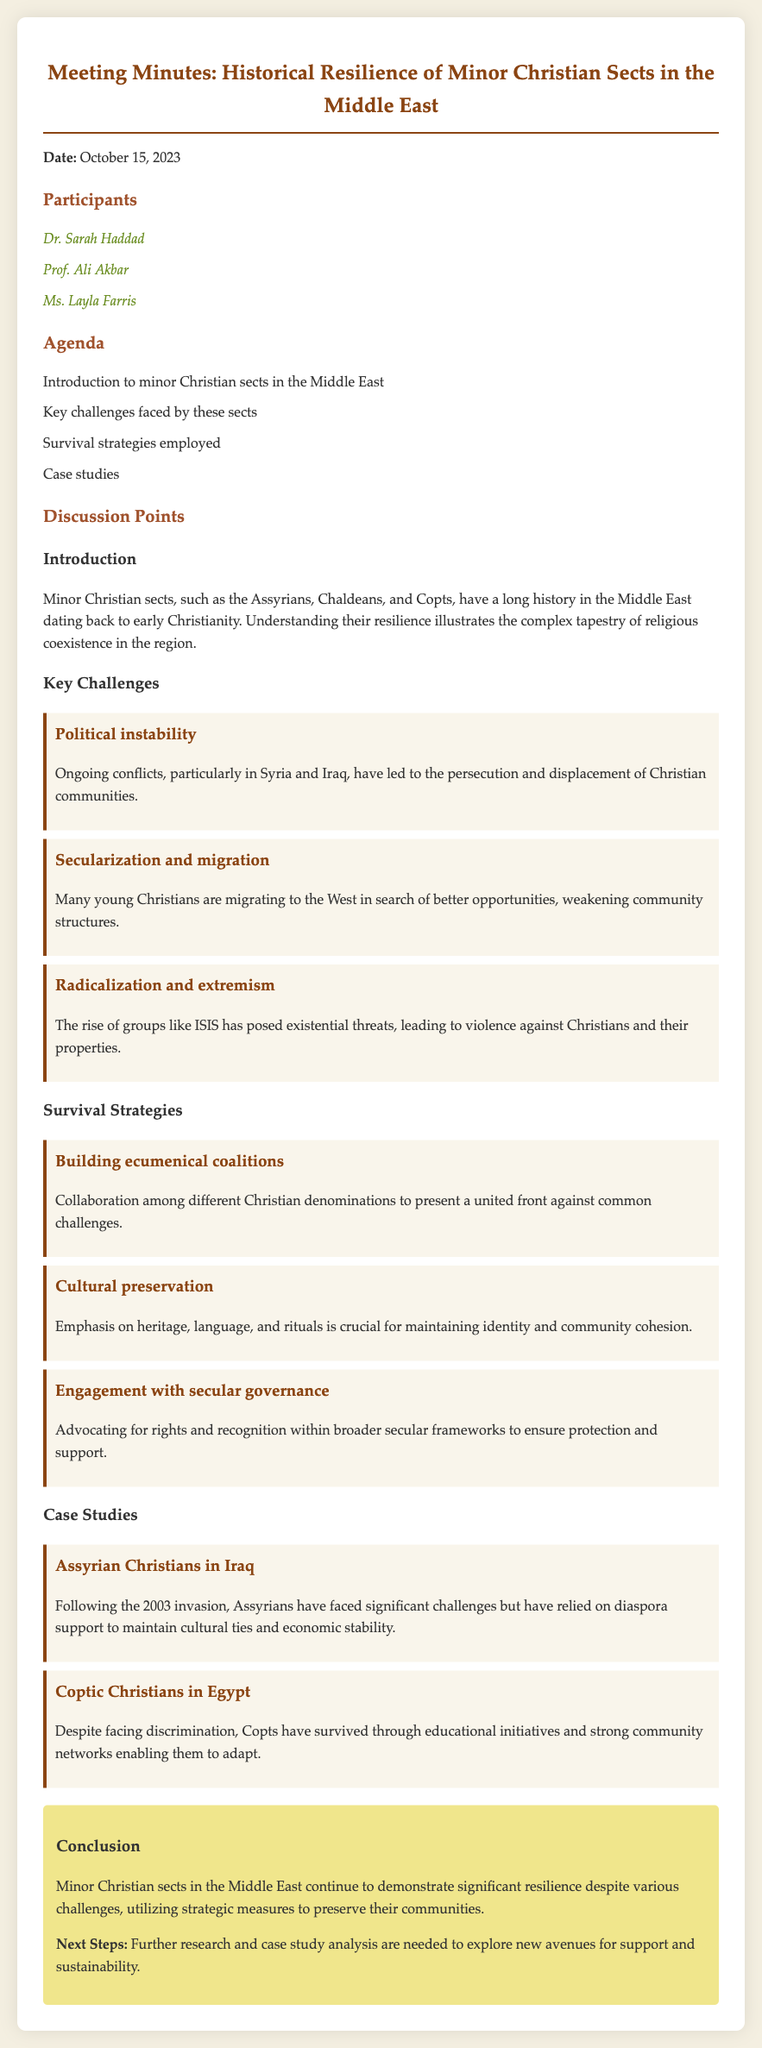What is the date of the meeting? The date of the meeting is clearly mentioned at the beginning of the document.
Answer: October 15, 2023 Who is one of the participants? The participants are listed under the section titled 'Participants.'
Answer: Dr. Sarah Haddad What is one key challenge faced by minor Christian sects? The key challenges are highlighted under the 'Key Challenges' section with specific headings.
Answer: Political instability What strategy involves collaboration among different Christian denominations? The strategies are categorized under the 'Survival Strategies' section with specific subheadings.
Answer: Building ecumenical coalitions What case study is presented about Assyrian Christians? The case studies are listed with their respective titles under the 'Case Studies' section.
Answer: Assyrian Christians in Iraq How have Coptic Christians survived in Egypt? The information regarding Coptic Christians' survival strategies is detailed in their case study.
Answer: Educational initiatives What is discussed after the case studies? The conclusion follows the case studies and summarizes the discussion points.
Answer: Conclusion How many participants are listed? The number of participants can be counted in the 'Participants' list section.
Answer: Three 